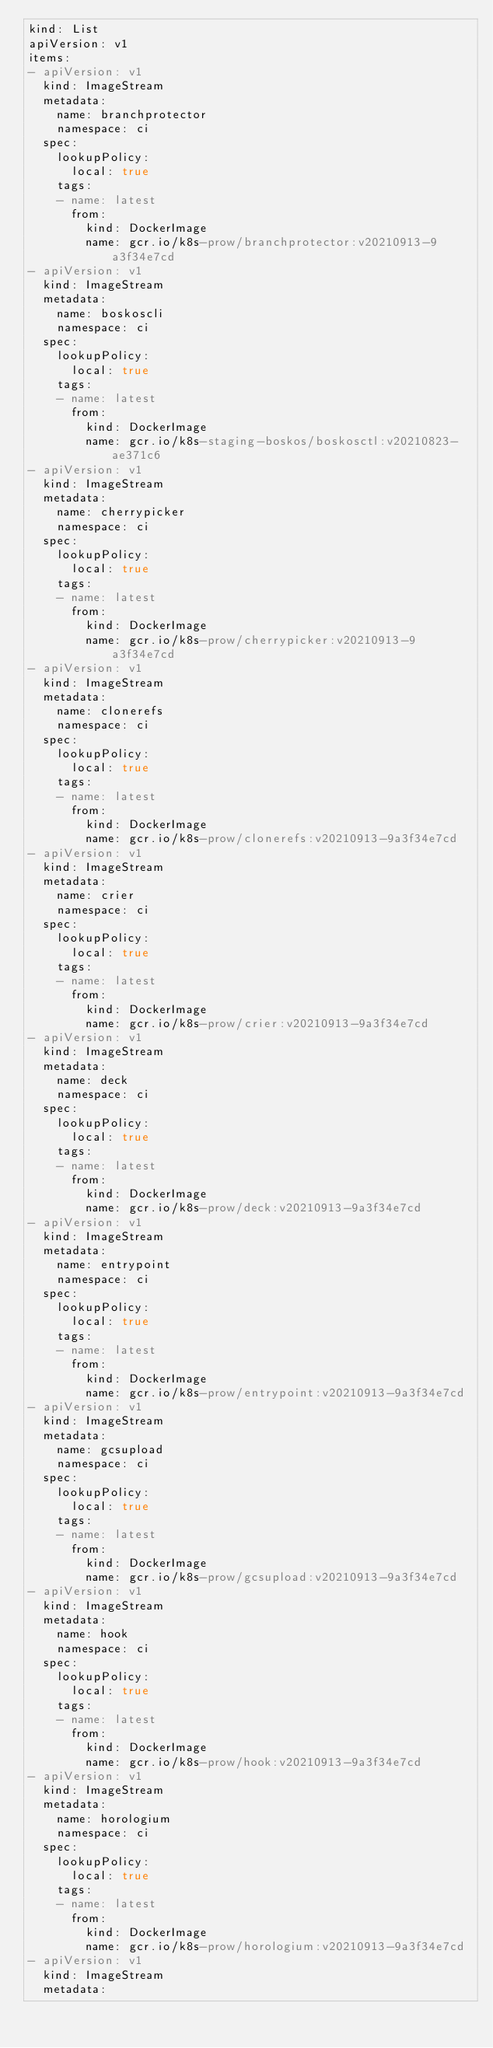Convert code to text. <code><loc_0><loc_0><loc_500><loc_500><_YAML_>kind: List
apiVersion: v1
items:
- apiVersion: v1
  kind: ImageStream
  metadata:
    name: branchprotector
    namespace: ci
  spec:
    lookupPolicy:
      local: true
    tags:
    - name: latest
      from:
        kind: DockerImage
        name: gcr.io/k8s-prow/branchprotector:v20210913-9a3f34e7cd
- apiVersion: v1
  kind: ImageStream
  metadata:
    name: boskoscli
    namespace: ci
  spec:
    lookupPolicy:
      local: true
    tags:
    - name: latest
      from:
        kind: DockerImage
        name: gcr.io/k8s-staging-boskos/boskosctl:v20210823-ae371c6
- apiVersion: v1
  kind: ImageStream
  metadata:
    name: cherrypicker
    namespace: ci
  spec:
    lookupPolicy:
      local: true
    tags:
    - name: latest
      from:
        kind: DockerImage
        name: gcr.io/k8s-prow/cherrypicker:v20210913-9a3f34e7cd
- apiVersion: v1
  kind: ImageStream
  metadata:
    name: clonerefs
    namespace: ci
  spec:
    lookupPolicy:
      local: true
    tags:
    - name: latest
      from:
        kind: DockerImage
        name: gcr.io/k8s-prow/clonerefs:v20210913-9a3f34e7cd
- apiVersion: v1
  kind: ImageStream
  metadata:
    name: crier
    namespace: ci
  spec:
    lookupPolicy:
      local: true
    tags:
    - name: latest
      from:
        kind: DockerImage
        name: gcr.io/k8s-prow/crier:v20210913-9a3f34e7cd
- apiVersion: v1
  kind: ImageStream
  metadata:
    name: deck
    namespace: ci
  spec:
    lookupPolicy:
      local: true
    tags:
    - name: latest
      from:
        kind: DockerImage
        name: gcr.io/k8s-prow/deck:v20210913-9a3f34e7cd
- apiVersion: v1
  kind: ImageStream
  metadata:
    name: entrypoint
    namespace: ci
  spec:
    lookupPolicy:
      local: true
    tags:
    - name: latest
      from:
        kind: DockerImage
        name: gcr.io/k8s-prow/entrypoint:v20210913-9a3f34e7cd
- apiVersion: v1
  kind: ImageStream
  metadata:
    name: gcsupload
    namespace: ci
  spec:
    lookupPolicy:
      local: true
    tags:
    - name: latest
      from:
        kind: DockerImage
        name: gcr.io/k8s-prow/gcsupload:v20210913-9a3f34e7cd
- apiVersion: v1
  kind: ImageStream
  metadata:
    name: hook
    namespace: ci
  spec:
    lookupPolicy:
      local: true
    tags:
    - name: latest
      from:
        kind: DockerImage
        name: gcr.io/k8s-prow/hook:v20210913-9a3f34e7cd
- apiVersion: v1
  kind: ImageStream
  metadata:
    name: horologium
    namespace: ci
  spec:
    lookupPolicy:
      local: true
    tags:
    - name: latest
      from:
        kind: DockerImage
        name: gcr.io/k8s-prow/horologium:v20210913-9a3f34e7cd
- apiVersion: v1
  kind: ImageStream
  metadata:</code> 